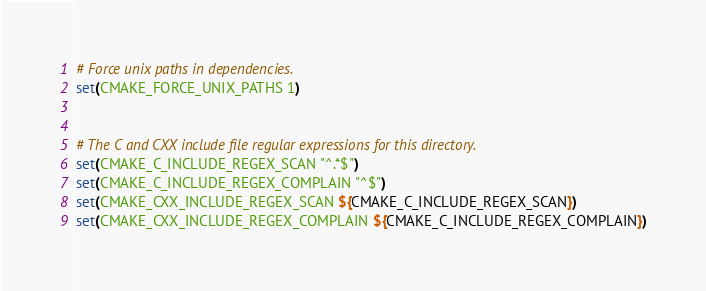Convert code to text. <code><loc_0><loc_0><loc_500><loc_500><_CMake_>
# Force unix paths in dependencies.
set(CMAKE_FORCE_UNIX_PATHS 1)


# The C and CXX include file regular expressions for this directory.
set(CMAKE_C_INCLUDE_REGEX_SCAN "^.*$")
set(CMAKE_C_INCLUDE_REGEX_COMPLAIN "^$")
set(CMAKE_CXX_INCLUDE_REGEX_SCAN ${CMAKE_C_INCLUDE_REGEX_SCAN})
set(CMAKE_CXX_INCLUDE_REGEX_COMPLAIN ${CMAKE_C_INCLUDE_REGEX_COMPLAIN})
</code> 